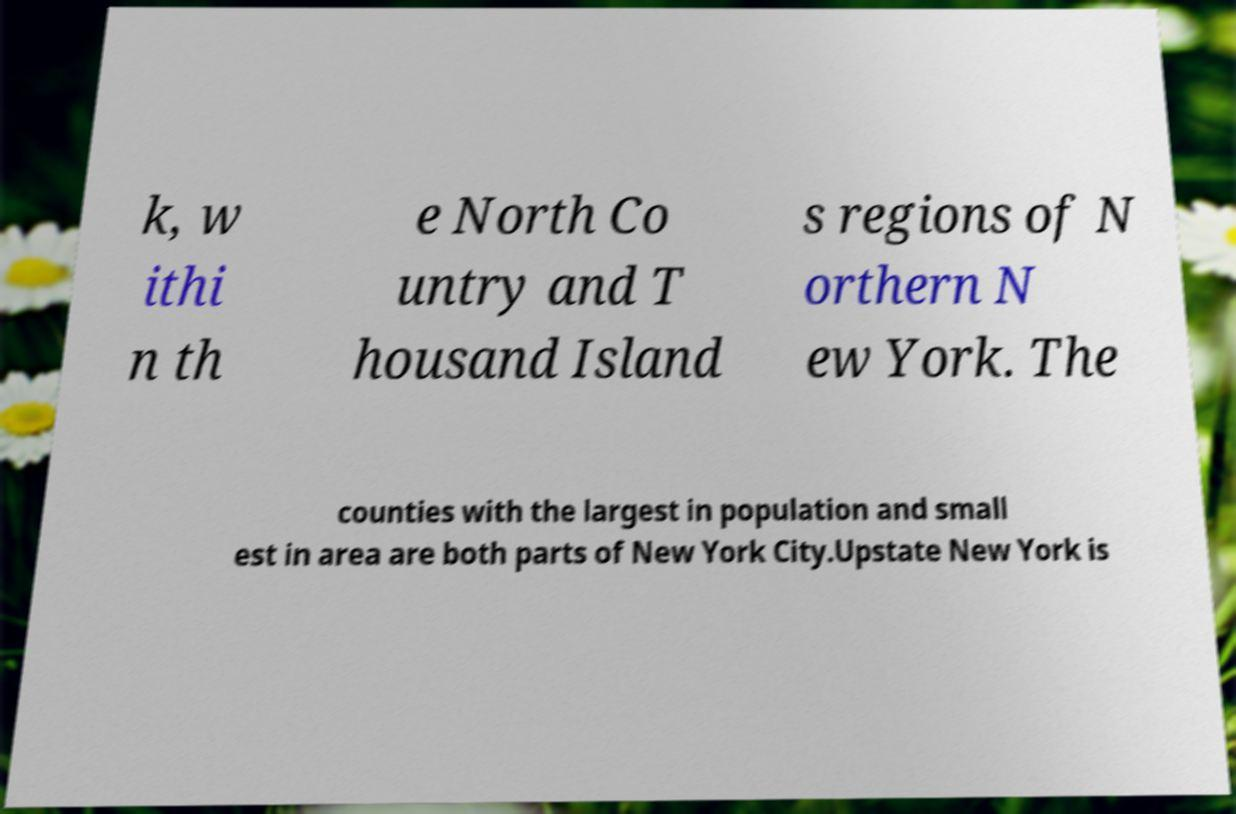Could you extract and type out the text from this image? k, w ithi n th e North Co untry and T housand Island s regions of N orthern N ew York. The counties with the largest in population and small est in area are both parts of New York City.Upstate New York is 